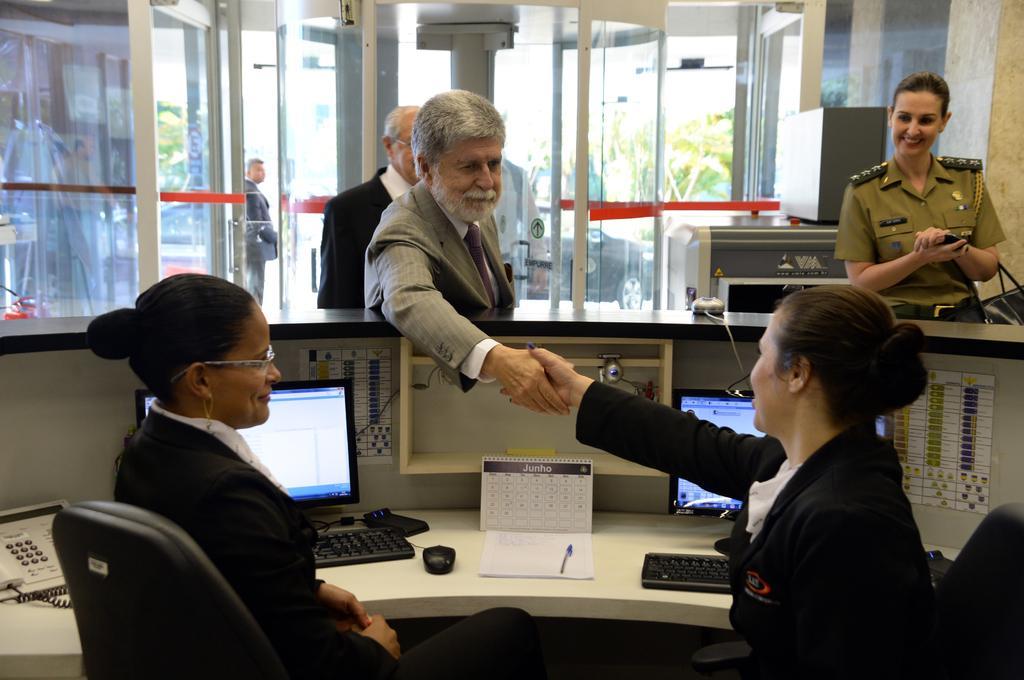In one or two sentences, can you explain what this image depicts? In this image there are two women with black suits and one of the woman is giving shake hand to the man. In the background there are also few persons. On the right there is a woman smiling. Glass windows and glass doors are visible in this image. Image also consists of two monitors, two keyboards, a book with a pen, a landline and these are placed on the white surface. Behind the glass window there are vehicles and also trees. 